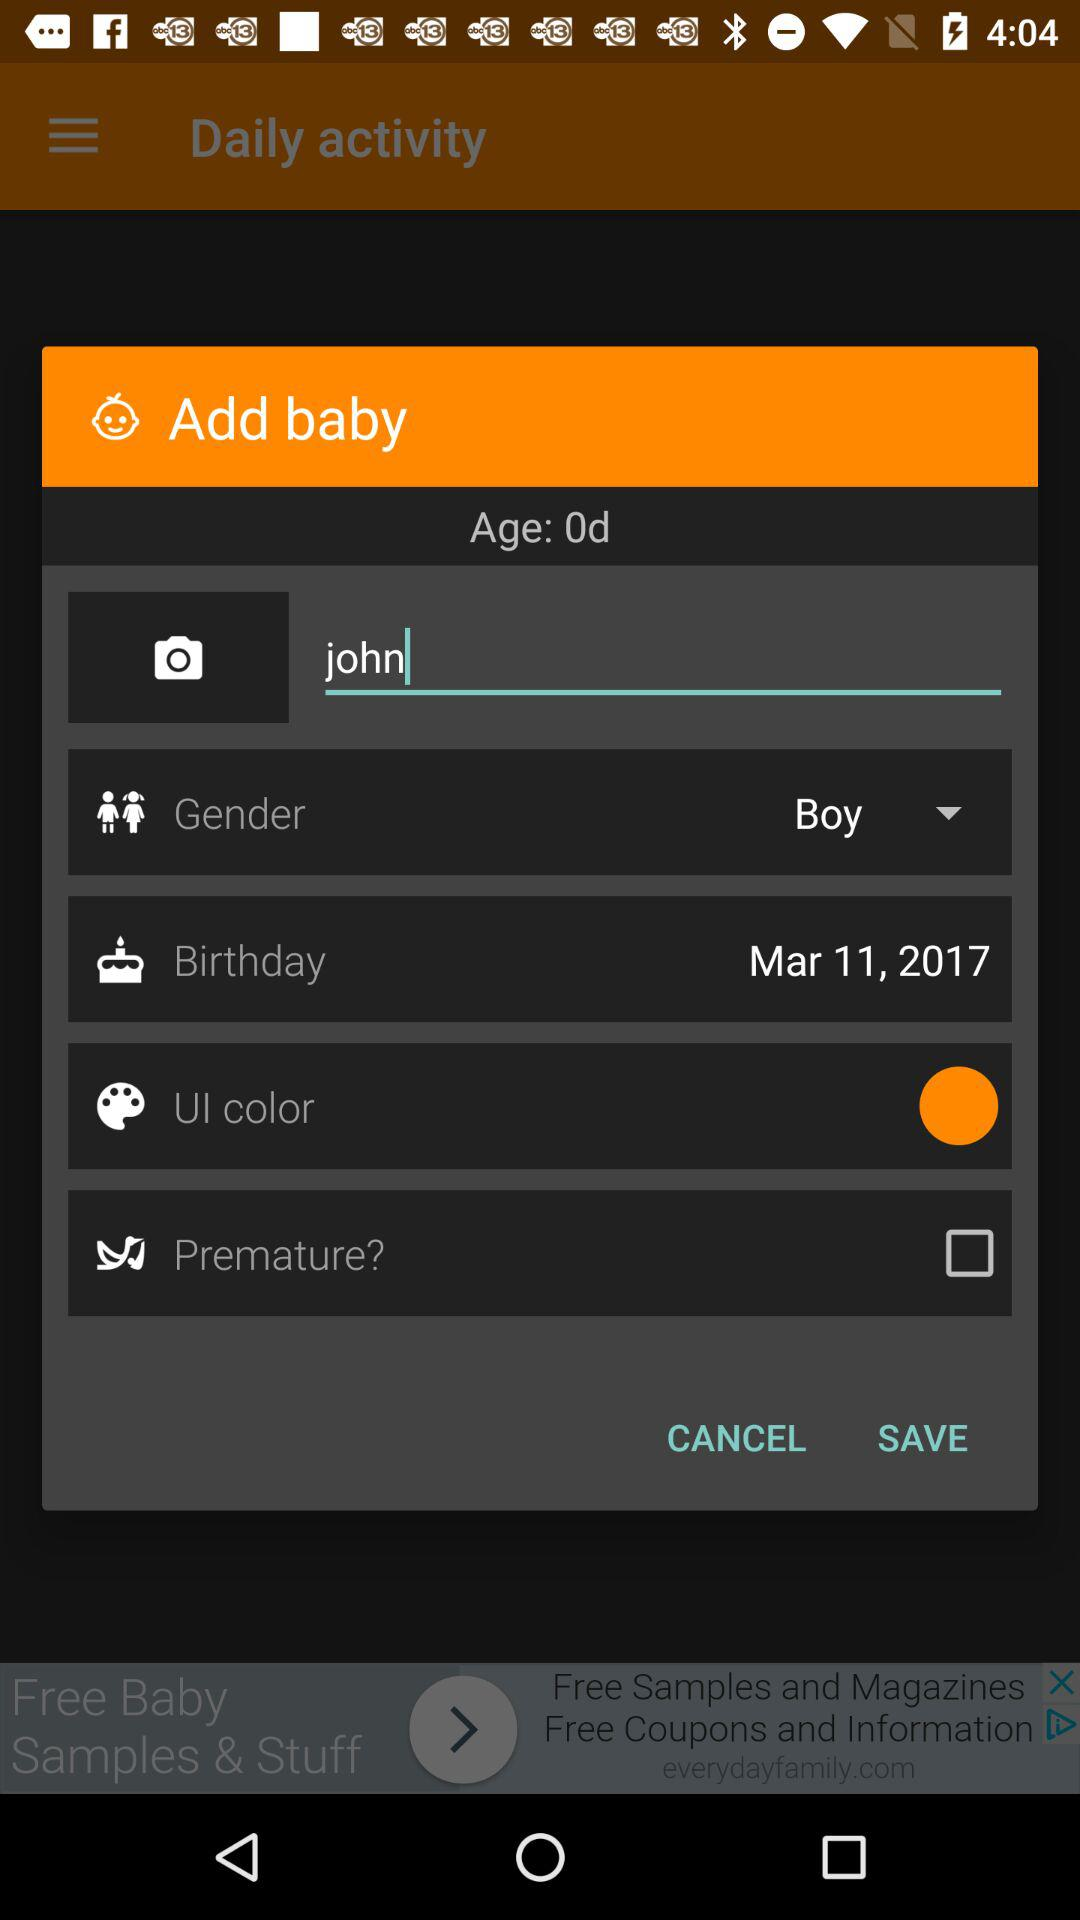What is the date of the birth of the baby? The date of birth is March 11, 2017. 